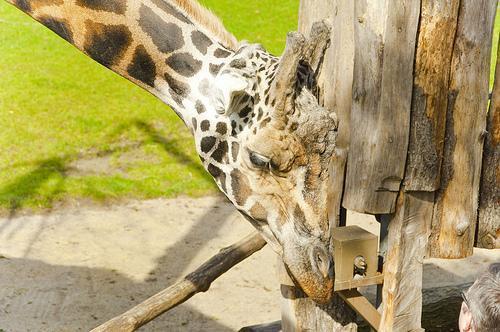How many giraffe are there?
Give a very brief answer. 1. 